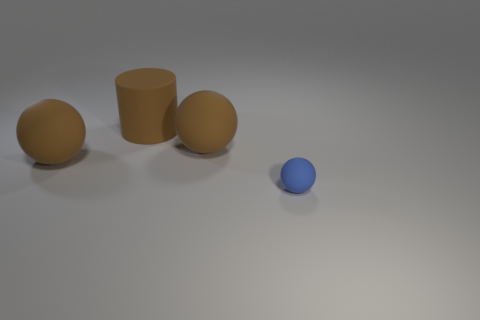Subtract all big spheres. How many spheres are left? 1 Subtract 1 cylinders. How many cylinders are left? 0 Add 2 big brown metallic cubes. How many objects exist? 6 Subtract all brown balls. How many balls are left? 1 Subtract all balls. How many objects are left? 1 Subtract all blue objects. Subtract all big red things. How many objects are left? 3 Add 2 big rubber cylinders. How many big rubber cylinders are left? 3 Add 2 gray matte cylinders. How many gray matte cylinders exist? 2 Subtract 0 gray cubes. How many objects are left? 4 Subtract all yellow spheres. Subtract all gray cylinders. How many spheres are left? 3 